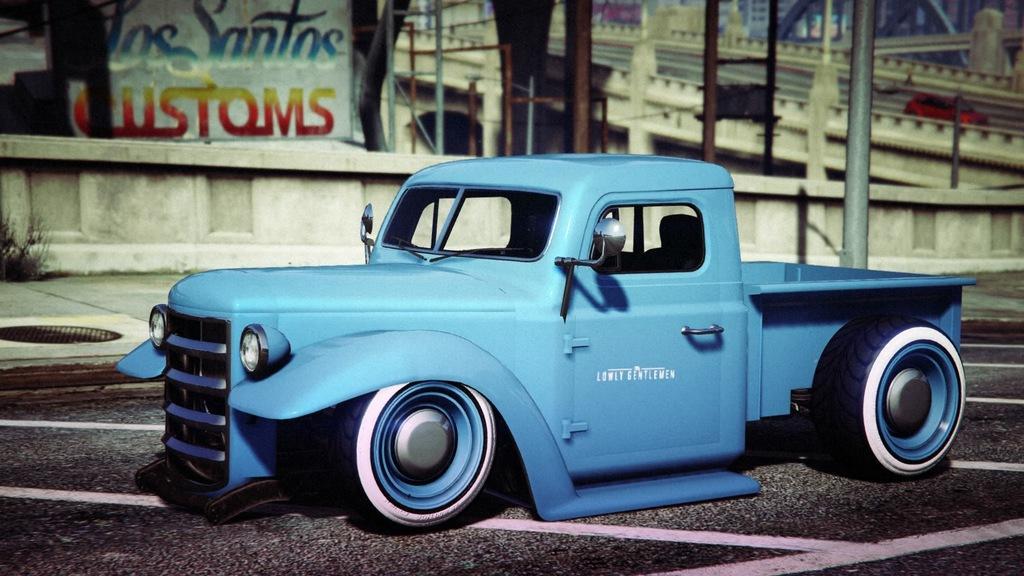Can you describe this image briefly? In this picture I can see a truck in front which is of blue in color and it is on the road. In the background I see the wall and on the right side of this image I see a bridge and on the top left of this image I see a board on which something is written. 